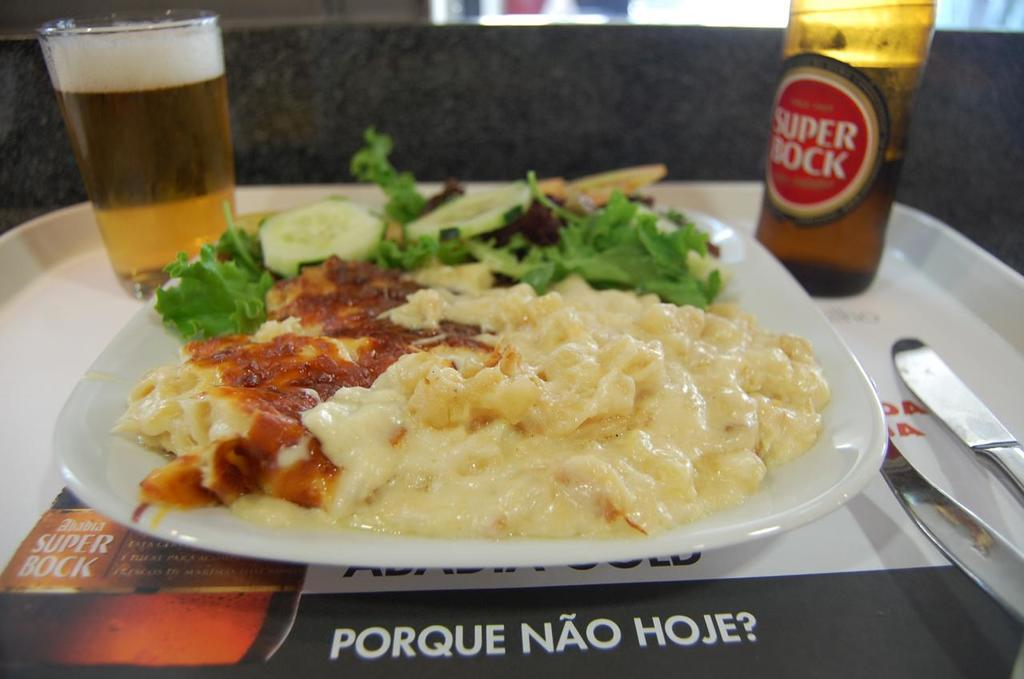What type of drink is in the glass on the tray? There is a glass of alcohol on the tray. What other beverage container is on the tray? There is a beer bottle on the tray. What is the purpose of the plate on the tray? The plate contains slices of cucumber and leafy vegetables, which suggests it is for serving food. What utensils are on the tray? There is a knife and a spoon on the tray. What type of food can be seen on the plate? The plate contains slices of cucumber and leafy vegetables, which are both types of food. How many children are playing in the snow in the image? There is no snow or children present in the image. What type of home is depicted in the image? The image does not show a home; it only shows a tray with various items on it. 